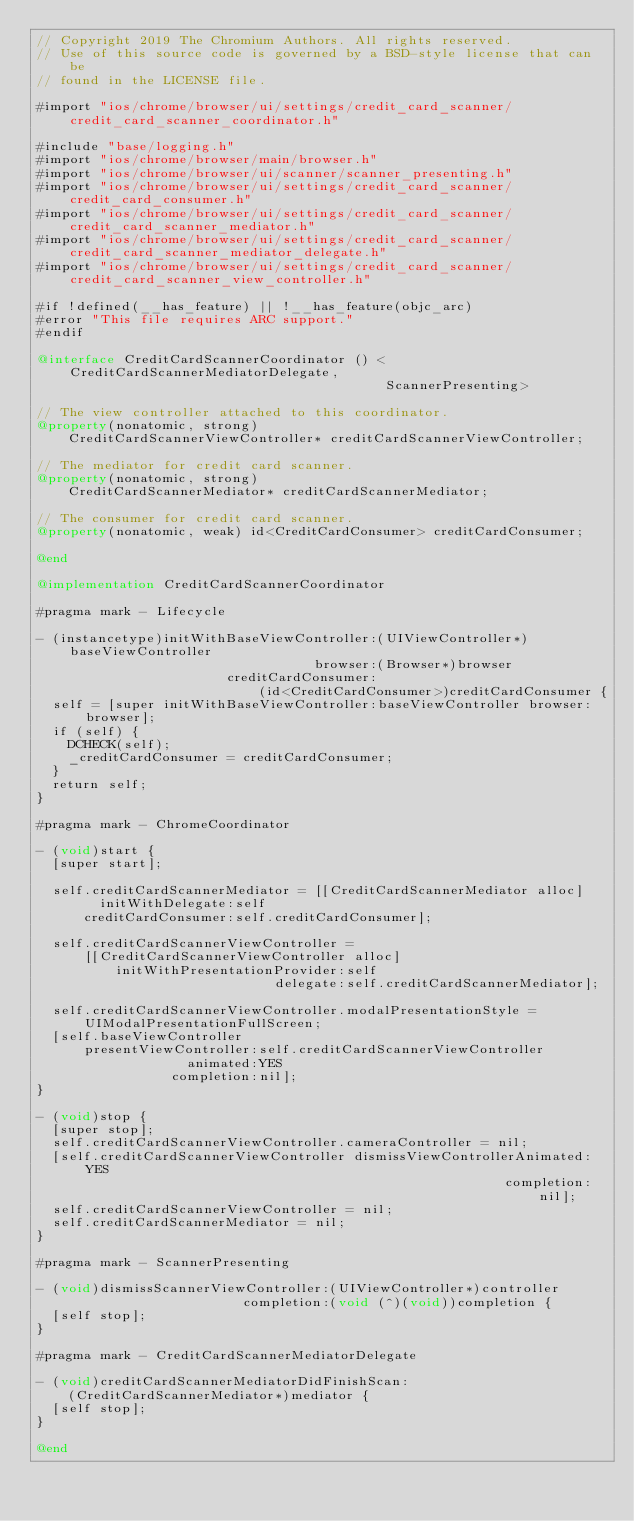Convert code to text. <code><loc_0><loc_0><loc_500><loc_500><_ObjectiveC_>// Copyright 2019 The Chromium Authors. All rights reserved.
// Use of this source code is governed by a BSD-style license that can be
// found in the LICENSE file.

#import "ios/chrome/browser/ui/settings/credit_card_scanner/credit_card_scanner_coordinator.h"

#include "base/logging.h"
#import "ios/chrome/browser/main/browser.h"
#import "ios/chrome/browser/ui/scanner/scanner_presenting.h"
#import "ios/chrome/browser/ui/settings/credit_card_scanner/credit_card_consumer.h"
#import "ios/chrome/browser/ui/settings/credit_card_scanner/credit_card_scanner_mediator.h"
#import "ios/chrome/browser/ui/settings/credit_card_scanner/credit_card_scanner_mediator_delegate.h"
#import "ios/chrome/browser/ui/settings/credit_card_scanner/credit_card_scanner_view_controller.h"

#if !defined(__has_feature) || !__has_feature(objc_arc)
#error "This file requires ARC support."
#endif

@interface CreditCardScannerCoordinator () <CreditCardScannerMediatorDelegate,
                                            ScannerPresenting>

// The view controller attached to this coordinator.
@property(nonatomic, strong)
    CreditCardScannerViewController* creditCardScannerViewController;

// The mediator for credit card scanner.
@property(nonatomic, strong)
    CreditCardScannerMediator* creditCardScannerMediator;

// The consumer for credit card scanner.
@property(nonatomic, weak) id<CreditCardConsumer> creditCardConsumer;

@end

@implementation CreditCardScannerCoordinator

#pragma mark - Lifecycle

- (instancetype)initWithBaseViewController:(UIViewController*)baseViewController
                                   browser:(Browser*)browser
                        creditCardConsumer:
                            (id<CreditCardConsumer>)creditCardConsumer {
  self = [super initWithBaseViewController:baseViewController browser:browser];
  if (self) {
    DCHECK(self);
    _creditCardConsumer = creditCardConsumer;
  }
  return self;
}

#pragma mark - ChromeCoordinator

- (void)start {
  [super start];

  self.creditCardScannerMediator = [[CreditCardScannerMediator alloc]
        initWithDelegate:self
      creditCardConsumer:self.creditCardConsumer];

  self.creditCardScannerViewController =
      [[CreditCardScannerViewController alloc]
          initWithPresentationProvider:self
                              delegate:self.creditCardScannerMediator];

  self.creditCardScannerViewController.modalPresentationStyle =
      UIModalPresentationFullScreen;
  [self.baseViewController
      presentViewController:self.creditCardScannerViewController
                   animated:YES
                 completion:nil];
}

- (void)stop {
  [super stop];
  self.creditCardScannerViewController.cameraController = nil;
  [self.creditCardScannerViewController dismissViewControllerAnimated:YES
                                                           completion:nil];
  self.creditCardScannerViewController = nil;
  self.creditCardScannerMediator = nil;
}

#pragma mark - ScannerPresenting

- (void)dismissScannerViewController:(UIViewController*)controller
                          completion:(void (^)(void))completion {
  [self stop];
}

#pragma mark - CreditCardScannerMediatorDelegate

- (void)creditCardScannerMediatorDidFinishScan:
    (CreditCardScannerMediator*)mediator {
  [self stop];
}

@end
</code> 